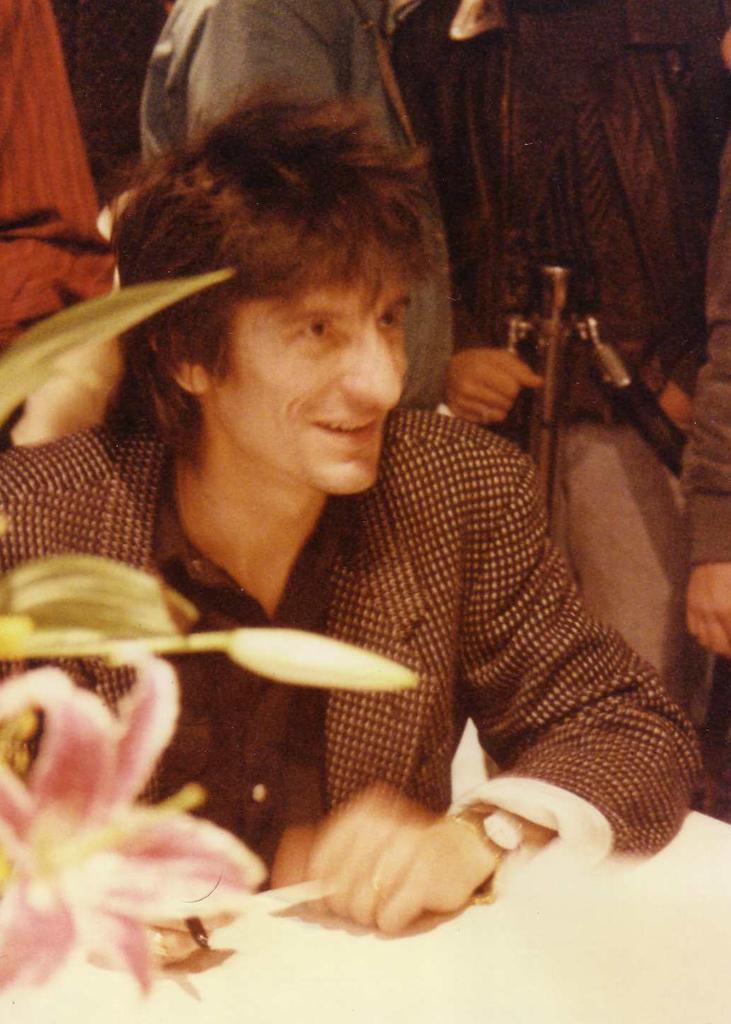Could you give a brief overview of what you see in this image? Here, we can see a man sitting and he is smiling, in the background there are some people standing. 